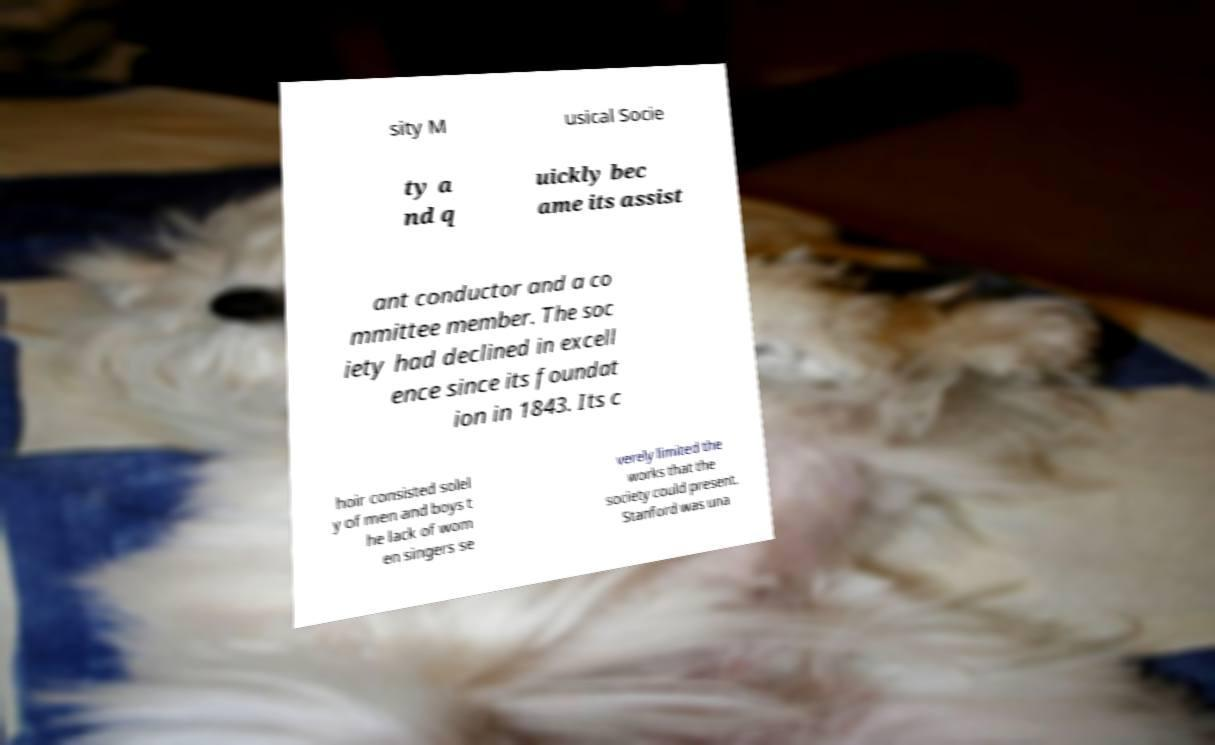Could you extract and type out the text from this image? sity M usical Socie ty a nd q uickly bec ame its assist ant conductor and a co mmittee member. The soc iety had declined in excell ence since its foundat ion in 1843. Its c hoir consisted solel y of men and boys t he lack of wom en singers se verely limited the works that the society could present. Stanford was una 